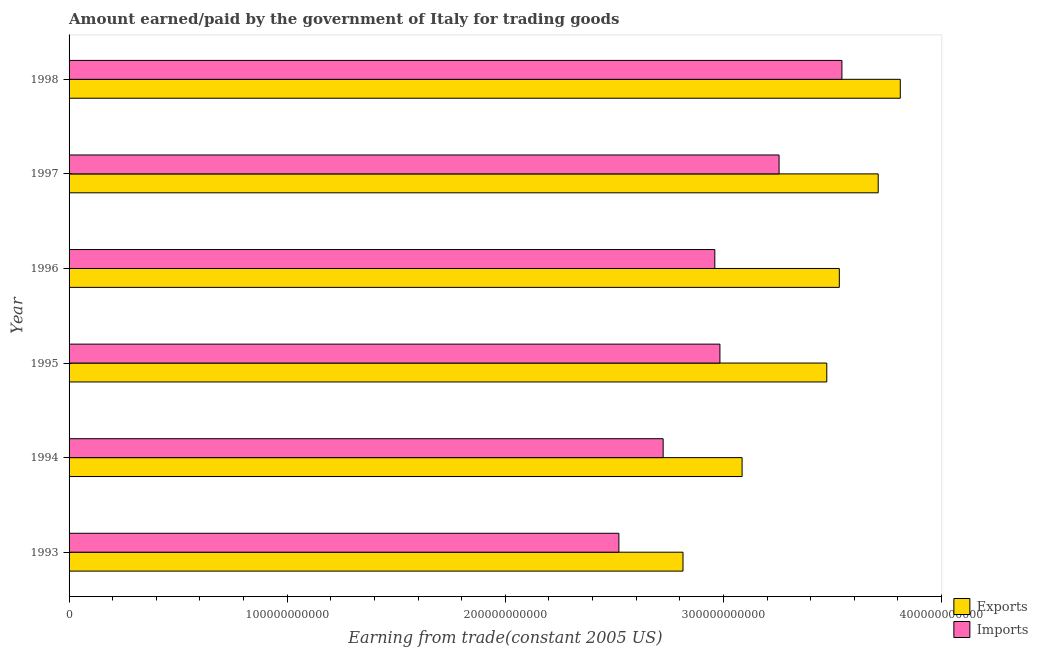How many different coloured bars are there?
Make the answer very short. 2. How many groups of bars are there?
Offer a terse response. 6. Are the number of bars per tick equal to the number of legend labels?
Your response must be concise. Yes. Are the number of bars on each tick of the Y-axis equal?
Provide a short and direct response. Yes. How many bars are there on the 3rd tick from the bottom?
Ensure brevity in your answer.  2. In how many cases, is the number of bars for a given year not equal to the number of legend labels?
Your response must be concise. 0. What is the amount paid for imports in 1998?
Make the answer very short. 3.54e+11. Across all years, what is the maximum amount paid for imports?
Your answer should be very brief. 3.54e+11. Across all years, what is the minimum amount earned from exports?
Your response must be concise. 2.81e+11. What is the total amount paid for imports in the graph?
Keep it short and to the point. 1.80e+12. What is the difference between the amount paid for imports in 1993 and that in 1997?
Provide a succinct answer. -7.34e+1. What is the difference between the amount paid for imports in 1995 and the amount earned from exports in 1996?
Keep it short and to the point. -5.47e+1. What is the average amount paid for imports per year?
Keep it short and to the point. 3.00e+11. In the year 1995, what is the difference between the amount earned from exports and amount paid for imports?
Give a very brief answer. 4.90e+1. What is the ratio of the amount earned from exports in 1993 to that in 1995?
Keep it short and to the point. 0.81. Is the amount earned from exports in 1994 less than that in 1996?
Your response must be concise. Yes. Is the difference between the amount earned from exports in 1996 and 1997 greater than the difference between the amount paid for imports in 1996 and 1997?
Your response must be concise. Yes. What is the difference between the highest and the second highest amount earned from exports?
Give a very brief answer. 1.01e+1. What is the difference between the highest and the lowest amount paid for imports?
Provide a short and direct response. 1.02e+11. What does the 1st bar from the top in 1998 represents?
Offer a very short reply. Imports. What does the 1st bar from the bottom in 1993 represents?
Your answer should be very brief. Exports. How many bars are there?
Make the answer very short. 12. What is the difference between two consecutive major ticks on the X-axis?
Offer a very short reply. 1.00e+11. Does the graph contain grids?
Give a very brief answer. No. Where does the legend appear in the graph?
Your answer should be very brief. Bottom right. How many legend labels are there?
Provide a succinct answer. 2. How are the legend labels stacked?
Your answer should be compact. Vertical. What is the title of the graph?
Provide a short and direct response. Amount earned/paid by the government of Italy for trading goods. What is the label or title of the X-axis?
Keep it short and to the point. Earning from trade(constant 2005 US). What is the Earning from trade(constant 2005 US) in Exports in 1993?
Provide a short and direct response. 2.81e+11. What is the Earning from trade(constant 2005 US) of Imports in 1993?
Provide a succinct answer. 2.52e+11. What is the Earning from trade(constant 2005 US) in Exports in 1994?
Your answer should be compact. 3.09e+11. What is the Earning from trade(constant 2005 US) of Imports in 1994?
Your response must be concise. 2.72e+11. What is the Earning from trade(constant 2005 US) in Exports in 1995?
Offer a very short reply. 3.47e+11. What is the Earning from trade(constant 2005 US) of Imports in 1995?
Your response must be concise. 2.98e+11. What is the Earning from trade(constant 2005 US) of Exports in 1996?
Ensure brevity in your answer.  3.53e+11. What is the Earning from trade(constant 2005 US) in Imports in 1996?
Provide a succinct answer. 2.96e+11. What is the Earning from trade(constant 2005 US) of Exports in 1997?
Your answer should be compact. 3.71e+11. What is the Earning from trade(constant 2005 US) of Imports in 1997?
Your answer should be compact. 3.26e+11. What is the Earning from trade(constant 2005 US) of Exports in 1998?
Give a very brief answer. 3.81e+11. What is the Earning from trade(constant 2005 US) of Imports in 1998?
Your answer should be very brief. 3.54e+11. Across all years, what is the maximum Earning from trade(constant 2005 US) in Exports?
Your answer should be compact. 3.81e+11. Across all years, what is the maximum Earning from trade(constant 2005 US) of Imports?
Offer a very short reply. 3.54e+11. Across all years, what is the minimum Earning from trade(constant 2005 US) of Exports?
Make the answer very short. 2.81e+11. Across all years, what is the minimum Earning from trade(constant 2005 US) in Imports?
Offer a terse response. 2.52e+11. What is the total Earning from trade(constant 2005 US) in Exports in the graph?
Provide a succinct answer. 2.04e+12. What is the total Earning from trade(constant 2005 US) of Imports in the graph?
Provide a short and direct response. 1.80e+12. What is the difference between the Earning from trade(constant 2005 US) of Exports in 1993 and that in 1994?
Provide a short and direct response. -2.71e+1. What is the difference between the Earning from trade(constant 2005 US) in Imports in 1993 and that in 1994?
Your answer should be compact. -2.03e+1. What is the difference between the Earning from trade(constant 2005 US) of Exports in 1993 and that in 1995?
Make the answer very short. -6.59e+1. What is the difference between the Earning from trade(constant 2005 US) in Imports in 1993 and that in 1995?
Offer a terse response. -4.63e+1. What is the difference between the Earning from trade(constant 2005 US) in Exports in 1993 and that in 1996?
Your response must be concise. -7.17e+1. What is the difference between the Earning from trade(constant 2005 US) of Imports in 1993 and that in 1996?
Provide a succinct answer. -4.40e+1. What is the difference between the Earning from trade(constant 2005 US) of Exports in 1993 and that in 1997?
Offer a terse response. -8.95e+1. What is the difference between the Earning from trade(constant 2005 US) of Imports in 1993 and that in 1997?
Keep it short and to the point. -7.34e+1. What is the difference between the Earning from trade(constant 2005 US) in Exports in 1993 and that in 1998?
Offer a very short reply. -9.96e+1. What is the difference between the Earning from trade(constant 2005 US) in Imports in 1993 and that in 1998?
Provide a short and direct response. -1.02e+11. What is the difference between the Earning from trade(constant 2005 US) of Exports in 1994 and that in 1995?
Keep it short and to the point. -3.88e+1. What is the difference between the Earning from trade(constant 2005 US) of Imports in 1994 and that in 1995?
Provide a succinct answer. -2.60e+1. What is the difference between the Earning from trade(constant 2005 US) in Exports in 1994 and that in 1996?
Provide a short and direct response. -4.46e+1. What is the difference between the Earning from trade(constant 2005 US) in Imports in 1994 and that in 1996?
Your response must be concise. -2.37e+1. What is the difference between the Earning from trade(constant 2005 US) in Exports in 1994 and that in 1997?
Give a very brief answer. -6.24e+1. What is the difference between the Earning from trade(constant 2005 US) in Imports in 1994 and that in 1997?
Keep it short and to the point. -5.31e+1. What is the difference between the Earning from trade(constant 2005 US) of Exports in 1994 and that in 1998?
Keep it short and to the point. -7.25e+1. What is the difference between the Earning from trade(constant 2005 US) in Imports in 1994 and that in 1998?
Give a very brief answer. -8.20e+1. What is the difference between the Earning from trade(constant 2005 US) in Exports in 1995 and that in 1996?
Provide a succinct answer. -5.75e+09. What is the difference between the Earning from trade(constant 2005 US) of Imports in 1995 and that in 1996?
Offer a terse response. 2.34e+09. What is the difference between the Earning from trade(constant 2005 US) in Exports in 1995 and that in 1997?
Your response must be concise. -2.36e+1. What is the difference between the Earning from trade(constant 2005 US) of Imports in 1995 and that in 1997?
Ensure brevity in your answer.  -2.71e+1. What is the difference between the Earning from trade(constant 2005 US) of Exports in 1995 and that in 1998?
Your answer should be compact. -3.37e+1. What is the difference between the Earning from trade(constant 2005 US) in Imports in 1995 and that in 1998?
Ensure brevity in your answer.  -5.59e+1. What is the difference between the Earning from trade(constant 2005 US) in Exports in 1996 and that in 1997?
Give a very brief answer. -1.78e+1. What is the difference between the Earning from trade(constant 2005 US) in Imports in 1996 and that in 1997?
Your response must be concise. -2.95e+1. What is the difference between the Earning from trade(constant 2005 US) of Exports in 1996 and that in 1998?
Provide a succinct answer. -2.79e+1. What is the difference between the Earning from trade(constant 2005 US) of Imports in 1996 and that in 1998?
Provide a succinct answer. -5.83e+1. What is the difference between the Earning from trade(constant 2005 US) of Exports in 1997 and that in 1998?
Your response must be concise. -1.01e+1. What is the difference between the Earning from trade(constant 2005 US) of Imports in 1997 and that in 1998?
Ensure brevity in your answer.  -2.88e+1. What is the difference between the Earning from trade(constant 2005 US) of Exports in 1993 and the Earning from trade(constant 2005 US) of Imports in 1994?
Make the answer very short. 9.09e+09. What is the difference between the Earning from trade(constant 2005 US) of Exports in 1993 and the Earning from trade(constant 2005 US) of Imports in 1995?
Your response must be concise. -1.69e+1. What is the difference between the Earning from trade(constant 2005 US) in Exports in 1993 and the Earning from trade(constant 2005 US) in Imports in 1996?
Offer a terse response. -1.46e+1. What is the difference between the Earning from trade(constant 2005 US) in Exports in 1993 and the Earning from trade(constant 2005 US) in Imports in 1997?
Ensure brevity in your answer.  -4.41e+1. What is the difference between the Earning from trade(constant 2005 US) of Exports in 1993 and the Earning from trade(constant 2005 US) of Imports in 1998?
Make the answer very short. -7.29e+1. What is the difference between the Earning from trade(constant 2005 US) in Exports in 1994 and the Earning from trade(constant 2005 US) in Imports in 1995?
Your response must be concise. 1.02e+1. What is the difference between the Earning from trade(constant 2005 US) in Exports in 1994 and the Earning from trade(constant 2005 US) in Imports in 1996?
Provide a short and direct response. 1.25e+1. What is the difference between the Earning from trade(constant 2005 US) of Exports in 1994 and the Earning from trade(constant 2005 US) of Imports in 1997?
Ensure brevity in your answer.  -1.70e+1. What is the difference between the Earning from trade(constant 2005 US) in Exports in 1994 and the Earning from trade(constant 2005 US) in Imports in 1998?
Provide a short and direct response. -4.58e+1. What is the difference between the Earning from trade(constant 2005 US) in Exports in 1995 and the Earning from trade(constant 2005 US) in Imports in 1996?
Your answer should be very brief. 5.13e+1. What is the difference between the Earning from trade(constant 2005 US) in Exports in 1995 and the Earning from trade(constant 2005 US) in Imports in 1997?
Ensure brevity in your answer.  2.19e+1. What is the difference between the Earning from trade(constant 2005 US) of Exports in 1995 and the Earning from trade(constant 2005 US) of Imports in 1998?
Your answer should be very brief. -6.94e+09. What is the difference between the Earning from trade(constant 2005 US) of Exports in 1996 and the Earning from trade(constant 2005 US) of Imports in 1997?
Your answer should be compact. 2.76e+1. What is the difference between the Earning from trade(constant 2005 US) in Exports in 1996 and the Earning from trade(constant 2005 US) in Imports in 1998?
Make the answer very short. -1.19e+09. What is the difference between the Earning from trade(constant 2005 US) of Exports in 1997 and the Earning from trade(constant 2005 US) of Imports in 1998?
Offer a terse response. 1.66e+1. What is the average Earning from trade(constant 2005 US) of Exports per year?
Offer a terse response. 3.40e+11. What is the average Earning from trade(constant 2005 US) of Imports per year?
Offer a very short reply. 3.00e+11. In the year 1993, what is the difference between the Earning from trade(constant 2005 US) in Exports and Earning from trade(constant 2005 US) in Imports?
Make the answer very short. 2.94e+1. In the year 1994, what is the difference between the Earning from trade(constant 2005 US) in Exports and Earning from trade(constant 2005 US) in Imports?
Your answer should be compact. 3.62e+1. In the year 1995, what is the difference between the Earning from trade(constant 2005 US) in Exports and Earning from trade(constant 2005 US) in Imports?
Offer a terse response. 4.90e+1. In the year 1996, what is the difference between the Earning from trade(constant 2005 US) in Exports and Earning from trade(constant 2005 US) in Imports?
Offer a terse response. 5.71e+1. In the year 1997, what is the difference between the Earning from trade(constant 2005 US) in Exports and Earning from trade(constant 2005 US) in Imports?
Your answer should be very brief. 4.54e+1. In the year 1998, what is the difference between the Earning from trade(constant 2005 US) in Exports and Earning from trade(constant 2005 US) in Imports?
Offer a terse response. 2.68e+1. What is the ratio of the Earning from trade(constant 2005 US) of Exports in 1993 to that in 1994?
Provide a succinct answer. 0.91. What is the ratio of the Earning from trade(constant 2005 US) in Imports in 1993 to that in 1994?
Keep it short and to the point. 0.93. What is the ratio of the Earning from trade(constant 2005 US) in Exports in 1993 to that in 1995?
Ensure brevity in your answer.  0.81. What is the ratio of the Earning from trade(constant 2005 US) of Imports in 1993 to that in 1995?
Provide a succinct answer. 0.84. What is the ratio of the Earning from trade(constant 2005 US) of Exports in 1993 to that in 1996?
Make the answer very short. 0.8. What is the ratio of the Earning from trade(constant 2005 US) of Imports in 1993 to that in 1996?
Provide a succinct answer. 0.85. What is the ratio of the Earning from trade(constant 2005 US) in Exports in 1993 to that in 1997?
Make the answer very short. 0.76. What is the ratio of the Earning from trade(constant 2005 US) of Imports in 1993 to that in 1997?
Provide a short and direct response. 0.77. What is the ratio of the Earning from trade(constant 2005 US) in Exports in 1993 to that in 1998?
Offer a terse response. 0.74. What is the ratio of the Earning from trade(constant 2005 US) of Imports in 1993 to that in 1998?
Your answer should be very brief. 0.71. What is the ratio of the Earning from trade(constant 2005 US) in Exports in 1994 to that in 1995?
Provide a succinct answer. 0.89. What is the ratio of the Earning from trade(constant 2005 US) in Imports in 1994 to that in 1995?
Keep it short and to the point. 0.91. What is the ratio of the Earning from trade(constant 2005 US) in Exports in 1994 to that in 1996?
Make the answer very short. 0.87. What is the ratio of the Earning from trade(constant 2005 US) in Exports in 1994 to that in 1997?
Offer a terse response. 0.83. What is the ratio of the Earning from trade(constant 2005 US) of Imports in 1994 to that in 1997?
Your answer should be compact. 0.84. What is the ratio of the Earning from trade(constant 2005 US) of Exports in 1994 to that in 1998?
Give a very brief answer. 0.81. What is the ratio of the Earning from trade(constant 2005 US) of Imports in 1994 to that in 1998?
Ensure brevity in your answer.  0.77. What is the ratio of the Earning from trade(constant 2005 US) of Exports in 1995 to that in 1996?
Provide a succinct answer. 0.98. What is the ratio of the Earning from trade(constant 2005 US) of Imports in 1995 to that in 1996?
Offer a very short reply. 1.01. What is the ratio of the Earning from trade(constant 2005 US) of Exports in 1995 to that in 1997?
Make the answer very short. 0.94. What is the ratio of the Earning from trade(constant 2005 US) of Imports in 1995 to that in 1997?
Make the answer very short. 0.92. What is the ratio of the Earning from trade(constant 2005 US) in Exports in 1995 to that in 1998?
Your answer should be very brief. 0.91. What is the ratio of the Earning from trade(constant 2005 US) in Imports in 1995 to that in 1998?
Keep it short and to the point. 0.84. What is the ratio of the Earning from trade(constant 2005 US) in Imports in 1996 to that in 1997?
Your response must be concise. 0.91. What is the ratio of the Earning from trade(constant 2005 US) in Exports in 1996 to that in 1998?
Make the answer very short. 0.93. What is the ratio of the Earning from trade(constant 2005 US) in Imports in 1996 to that in 1998?
Provide a succinct answer. 0.84. What is the ratio of the Earning from trade(constant 2005 US) of Exports in 1997 to that in 1998?
Give a very brief answer. 0.97. What is the ratio of the Earning from trade(constant 2005 US) in Imports in 1997 to that in 1998?
Your response must be concise. 0.92. What is the difference between the highest and the second highest Earning from trade(constant 2005 US) of Exports?
Offer a terse response. 1.01e+1. What is the difference between the highest and the second highest Earning from trade(constant 2005 US) in Imports?
Give a very brief answer. 2.88e+1. What is the difference between the highest and the lowest Earning from trade(constant 2005 US) of Exports?
Your response must be concise. 9.96e+1. What is the difference between the highest and the lowest Earning from trade(constant 2005 US) of Imports?
Your response must be concise. 1.02e+11. 